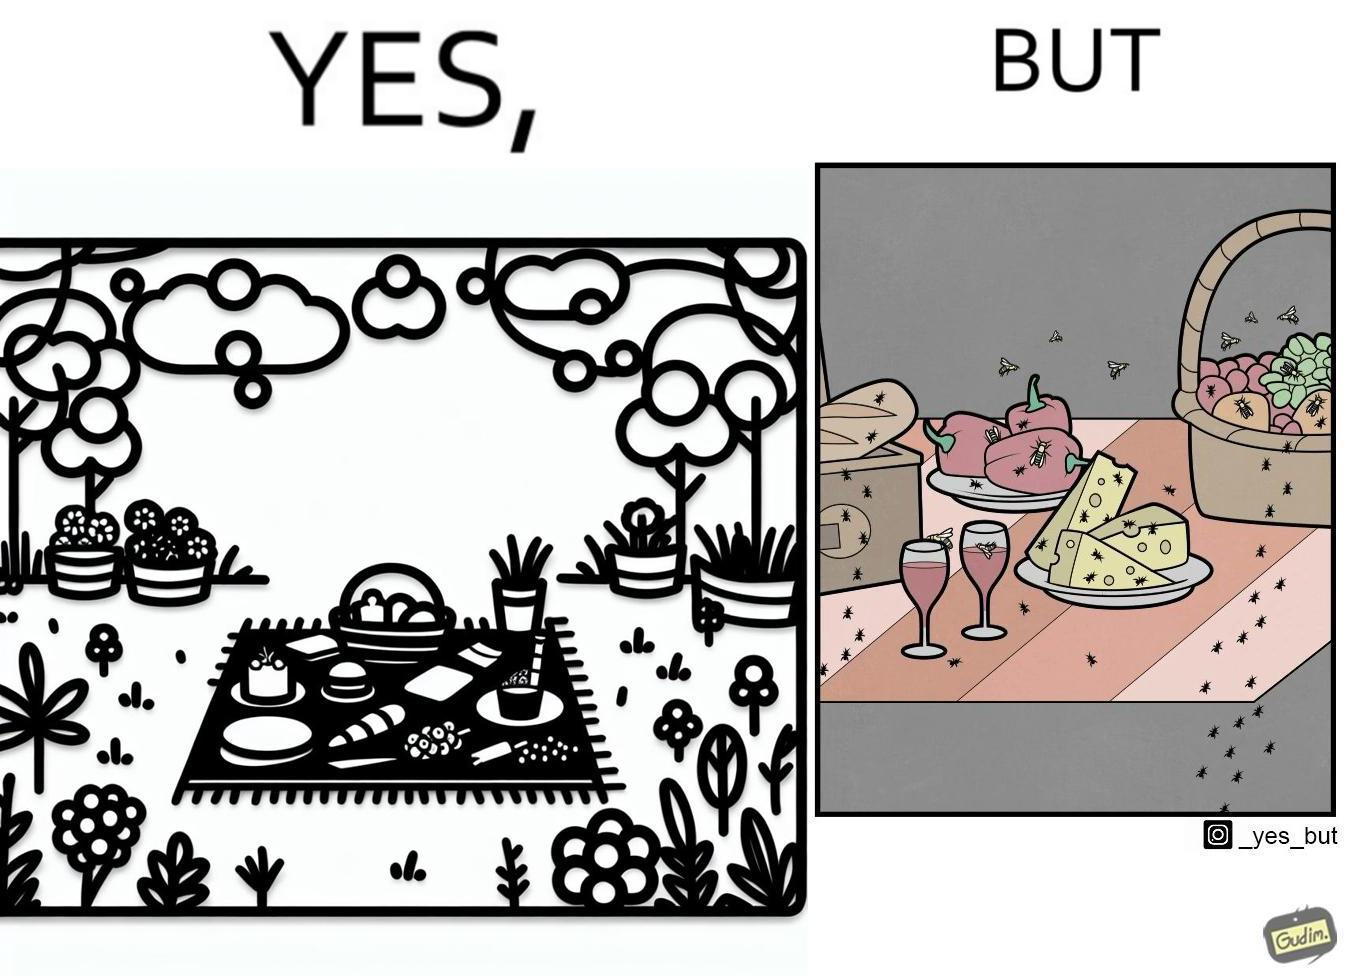Compare the left and right sides of this image. In the left part of the image: The food is kept on a blanket in a garden. In the right part of the image: Some bugs are attracting towards the food. 